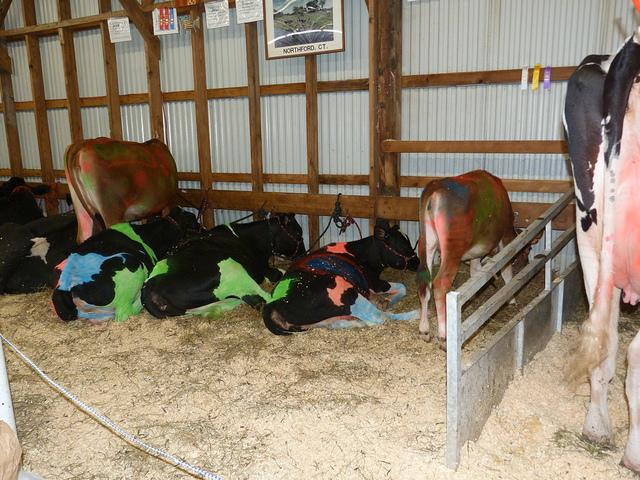What made the cows unnatural colors?

Choices:
A) spray paint
B) hair dye
C) crayons
D) markers spray paint 